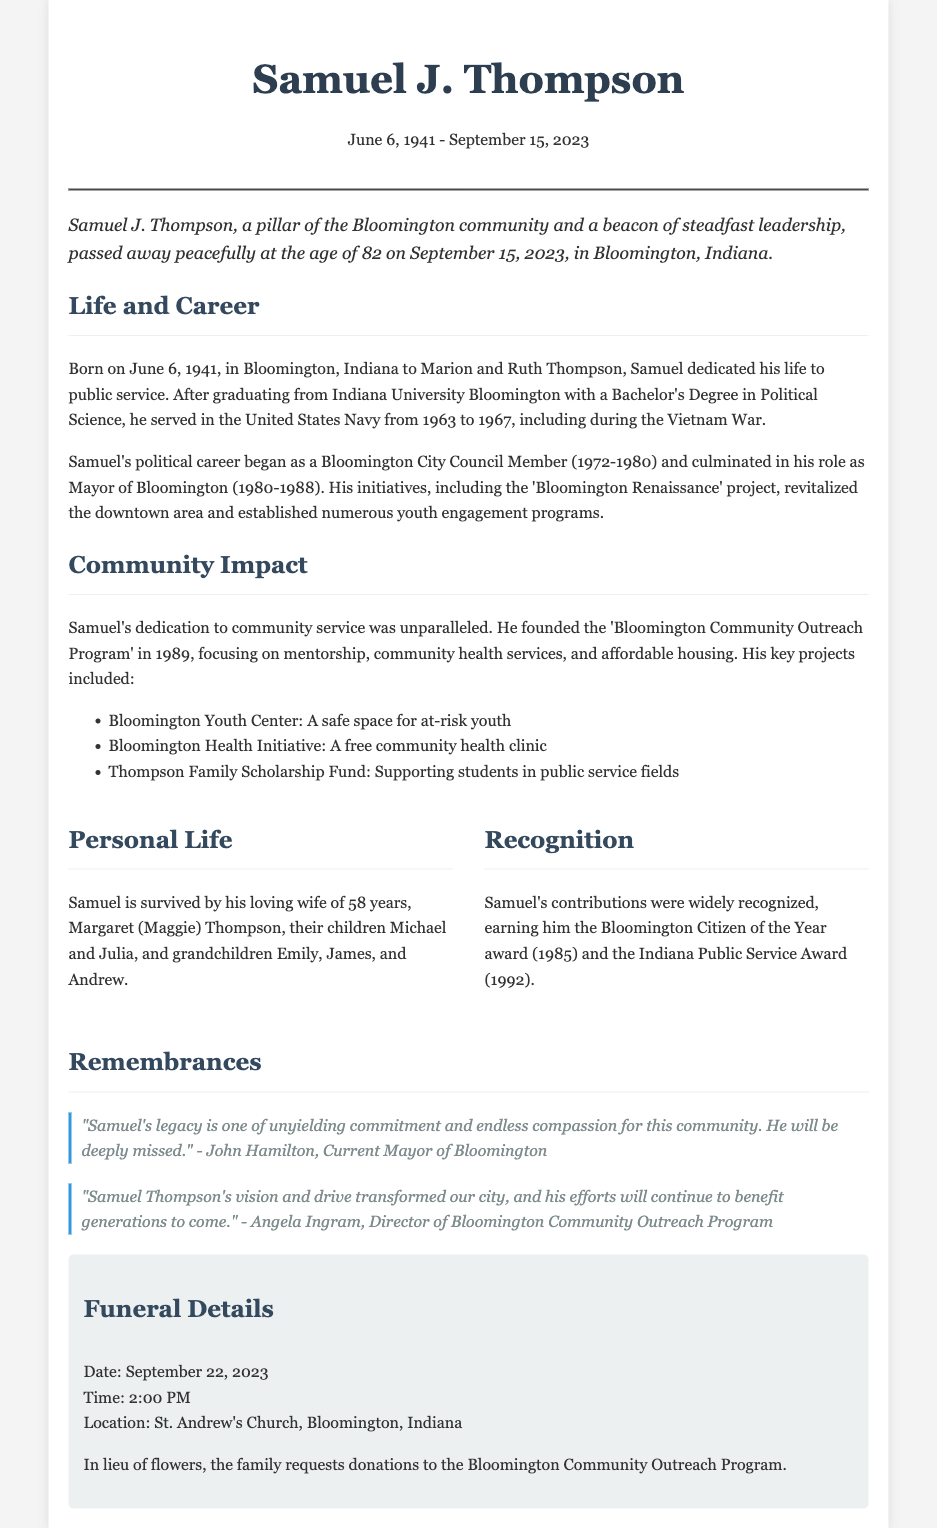What was Samuel J. Thompson's date of birth? The document states that Samuel J. Thompson was born on June 6, 1941.
Answer: June 6, 1941 What position did Samuel J. Thompson hold from 1980 to 1988? The document mentions that he served as Mayor of Bloomington during those years.
Answer: Mayor of Bloomington What award did Samuel receive in 1985? It is noted in the document that he received the Bloomington Citizen of the Year award in 1985.
Answer: Bloomington Citizen of the Year What initiative did he found in 1989? The obituary highlights that he founded the Bloomington Community Outreach Program in that year.
Answer: Bloomington Community Outreach Program How many grandchildren did Samuel J. Thompson have? The document lists three grandchildren: Emily, James, and Andrew.
Answer: Three What was one of the key projects under the Bloomington Community Outreach Program? The document lists several key projects including the Bloomington Youth Center.
Answer: Bloomington Youth Center What was Samuel’s profession after his education? The obituary indicates he dedicated his life to public service after graduating.
Answer: Public service What is mentioned as the location of the funeral? The document specifies that the funeral will take place at St. Andrew's Church, Bloomington, Indiana.
Answer: St. Andrew's Church, Bloomington, Indiana 